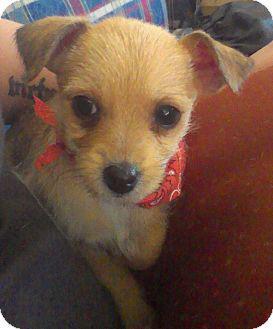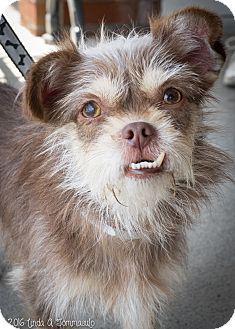The first image is the image on the left, the second image is the image on the right. Considering the images on both sides, is "One of the dogs has a body part that is normally inside the mouth being shown outside of the mouth." valid? Answer yes or no. Yes. The first image is the image on the left, the second image is the image on the right. Examine the images to the left and right. Is the description "One image shows a dog whose mouth isn't fully closed." accurate? Answer yes or no. Yes. 